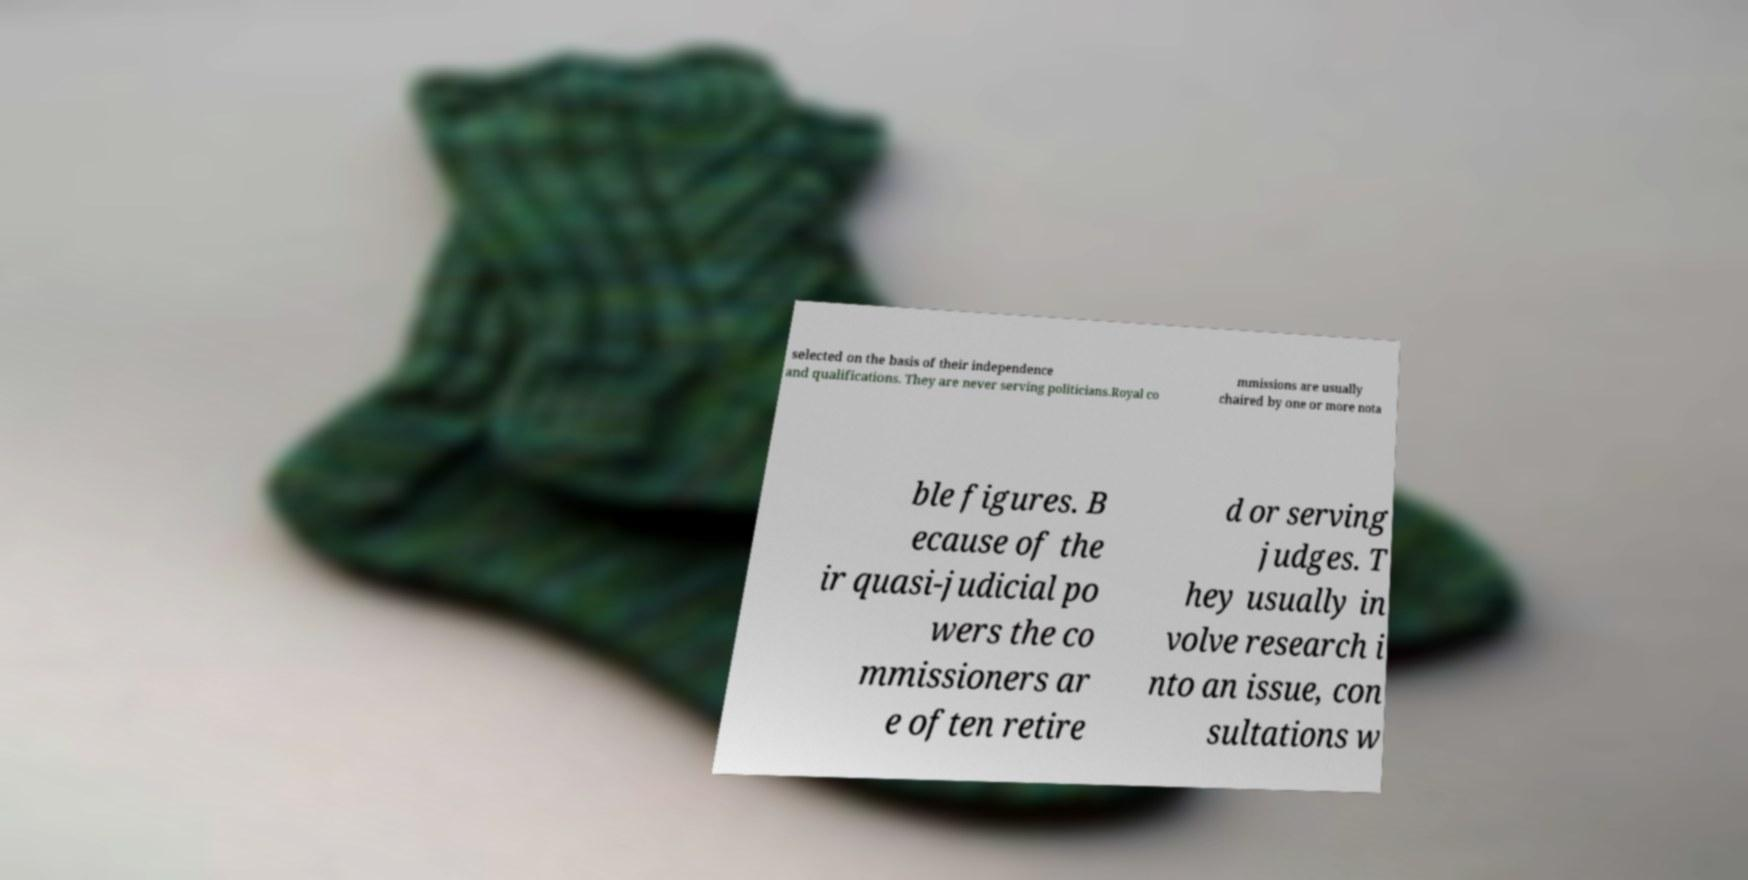I need the written content from this picture converted into text. Can you do that? selected on the basis of their independence and qualifications. They are never serving politicians.Royal co mmissions are usually chaired by one or more nota ble figures. B ecause of the ir quasi-judicial po wers the co mmissioners ar e often retire d or serving judges. T hey usually in volve research i nto an issue, con sultations w 